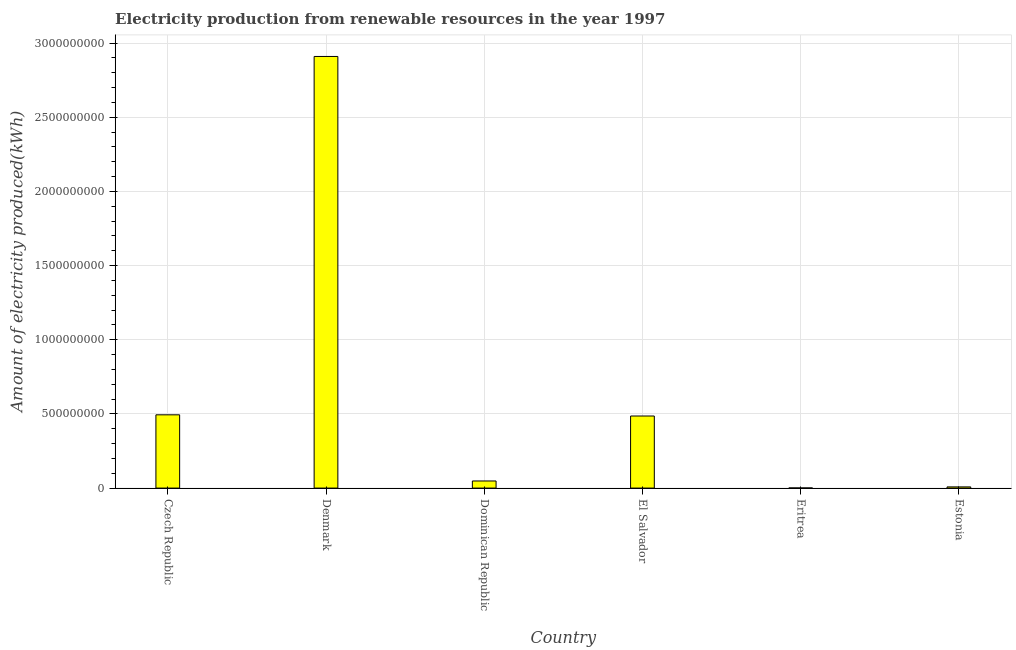Does the graph contain grids?
Your response must be concise. Yes. What is the title of the graph?
Ensure brevity in your answer.  Electricity production from renewable resources in the year 1997. What is the label or title of the Y-axis?
Keep it short and to the point. Amount of electricity produced(kWh). Across all countries, what is the maximum amount of electricity produced?
Give a very brief answer. 2.91e+09. Across all countries, what is the minimum amount of electricity produced?
Offer a terse response. 1.00e+06. In which country was the amount of electricity produced maximum?
Keep it short and to the point. Denmark. In which country was the amount of electricity produced minimum?
Make the answer very short. Eritrea. What is the sum of the amount of electricity produced?
Keep it short and to the point. 3.95e+09. What is the difference between the amount of electricity produced in Eritrea and Estonia?
Provide a short and direct response. -7.00e+06. What is the average amount of electricity produced per country?
Provide a succinct answer. 6.58e+08. What is the median amount of electricity produced?
Your answer should be compact. 2.67e+08. What is the ratio of the amount of electricity produced in Czech Republic to that in Estonia?
Offer a terse response. 61.75. Is the difference between the amount of electricity produced in Denmark and Eritrea greater than the difference between any two countries?
Offer a very short reply. Yes. What is the difference between the highest and the second highest amount of electricity produced?
Ensure brevity in your answer.  2.42e+09. Is the sum of the amount of electricity produced in El Salvador and Estonia greater than the maximum amount of electricity produced across all countries?
Your answer should be compact. No. What is the difference between the highest and the lowest amount of electricity produced?
Provide a short and direct response. 2.91e+09. How many bars are there?
Provide a succinct answer. 6. What is the difference between two consecutive major ticks on the Y-axis?
Your answer should be very brief. 5.00e+08. Are the values on the major ticks of Y-axis written in scientific E-notation?
Make the answer very short. No. What is the Amount of electricity produced(kWh) of Czech Republic?
Make the answer very short. 4.94e+08. What is the Amount of electricity produced(kWh) in Denmark?
Provide a short and direct response. 2.91e+09. What is the Amount of electricity produced(kWh) in Dominican Republic?
Make the answer very short. 4.80e+07. What is the Amount of electricity produced(kWh) in El Salvador?
Provide a short and direct response. 4.86e+08. What is the Amount of electricity produced(kWh) in Estonia?
Provide a short and direct response. 8.00e+06. What is the difference between the Amount of electricity produced(kWh) in Czech Republic and Denmark?
Keep it short and to the point. -2.42e+09. What is the difference between the Amount of electricity produced(kWh) in Czech Republic and Dominican Republic?
Your answer should be very brief. 4.46e+08. What is the difference between the Amount of electricity produced(kWh) in Czech Republic and Eritrea?
Keep it short and to the point. 4.93e+08. What is the difference between the Amount of electricity produced(kWh) in Czech Republic and Estonia?
Offer a terse response. 4.86e+08. What is the difference between the Amount of electricity produced(kWh) in Denmark and Dominican Republic?
Your answer should be very brief. 2.86e+09. What is the difference between the Amount of electricity produced(kWh) in Denmark and El Salvador?
Provide a short and direct response. 2.42e+09. What is the difference between the Amount of electricity produced(kWh) in Denmark and Eritrea?
Ensure brevity in your answer.  2.91e+09. What is the difference between the Amount of electricity produced(kWh) in Denmark and Estonia?
Provide a succinct answer. 2.90e+09. What is the difference between the Amount of electricity produced(kWh) in Dominican Republic and El Salvador?
Offer a very short reply. -4.38e+08. What is the difference between the Amount of electricity produced(kWh) in Dominican Republic and Eritrea?
Give a very brief answer. 4.70e+07. What is the difference between the Amount of electricity produced(kWh) in Dominican Republic and Estonia?
Your answer should be compact. 4.00e+07. What is the difference between the Amount of electricity produced(kWh) in El Salvador and Eritrea?
Keep it short and to the point. 4.85e+08. What is the difference between the Amount of electricity produced(kWh) in El Salvador and Estonia?
Keep it short and to the point. 4.78e+08. What is the difference between the Amount of electricity produced(kWh) in Eritrea and Estonia?
Your answer should be compact. -7.00e+06. What is the ratio of the Amount of electricity produced(kWh) in Czech Republic to that in Denmark?
Your answer should be very brief. 0.17. What is the ratio of the Amount of electricity produced(kWh) in Czech Republic to that in Dominican Republic?
Your answer should be very brief. 10.29. What is the ratio of the Amount of electricity produced(kWh) in Czech Republic to that in Eritrea?
Offer a terse response. 494. What is the ratio of the Amount of electricity produced(kWh) in Czech Republic to that in Estonia?
Your response must be concise. 61.75. What is the ratio of the Amount of electricity produced(kWh) in Denmark to that in Dominican Republic?
Keep it short and to the point. 60.62. What is the ratio of the Amount of electricity produced(kWh) in Denmark to that in El Salvador?
Ensure brevity in your answer.  5.99. What is the ratio of the Amount of electricity produced(kWh) in Denmark to that in Eritrea?
Your answer should be very brief. 2910. What is the ratio of the Amount of electricity produced(kWh) in Denmark to that in Estonia?
Keep it short and to the point. 363.75. What is the ratio of the Amount of electricity produced(kWh) in Dominican Republic to that in El Salvador?
Your answer should be very brief. 0.1. What is the ratio of the Amount of electricity produced(kWh) in El Salvador to that in Eritrea?
Provide a succinct answer. 486. What is the ratio of the Amount of electricity produced(kWh) in El Salvador to that in Estonia?
Provide a succinct answer. 60.75. 